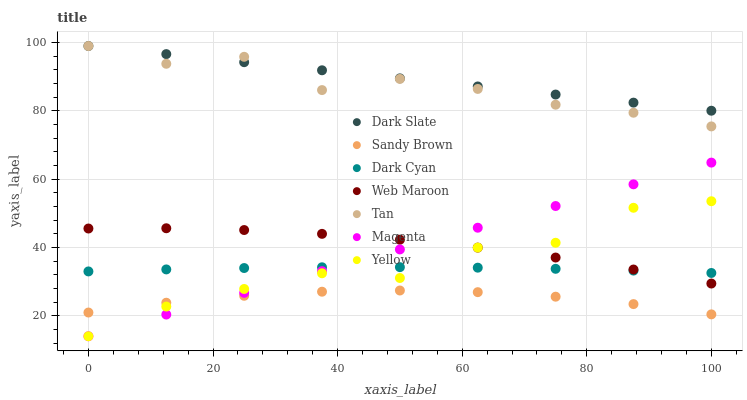Does Sandy Brown have the minimum area under the curve?
Answer yes or no. Yes. Does Dark Slate have the maximum area under the curve?
Answer yes or no. Yes. Does Yellow have the minimum area under the curve?
Answer yes or no. No. Does Yellow have the maximum area under the curve?
Answer yes or no. No. Is Magenta the smoothest?
Answer yes or no. Yes. Is Yellow the roughest?
Answer yes or no. Yes. Is Dark Slate the smoothest?
Answer yes or no. No. Is Dark Slate the roughest?
Answer yes or no. No. Does Yellow have the lowest value?
Answer yes or no. Yes. Does Dark Slate have the lowest value?
Answer yes or no. No. Does Tan have the highest value?
Answer yes or no. Yes. Does Yellow have the highest value?
Answer yes or no. No. Is Sandy Brown less than Web Maroon?
Answer yes or no. Yes. Is Web Maroon greater than Sandy Brown?
Answer yes or no. Yes. Does Web Maroon intersect Magenta?
Answer yes or no. Yes. Is Web Maroon less than Magenta?
Answer yes or no. No. Is Web Maroon greater than Magenta?
Answer yes or no. No. Does Sandy Brown intersect Web Maroon?
Answer yes or no. No. 